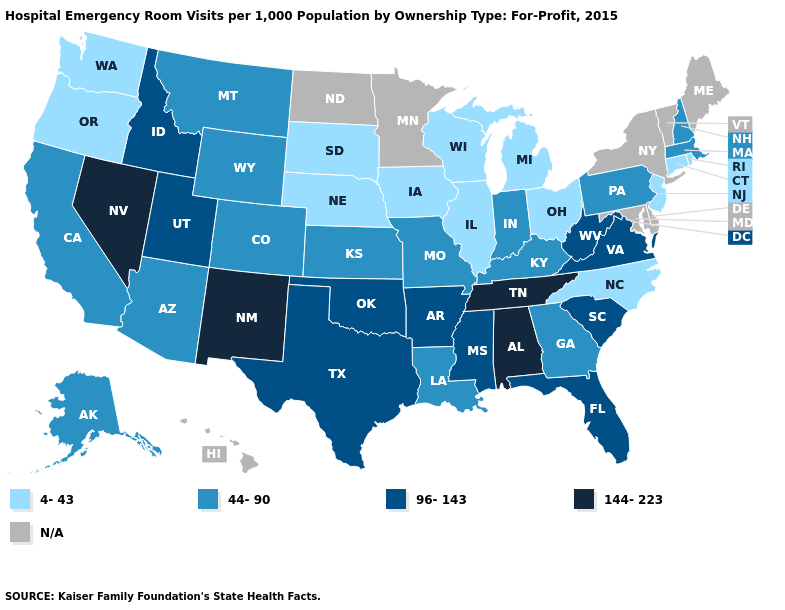What is the highest value in the West ?
Be succinct. 144-223. Name the states that have a value in the range 144-223?
Concise answer only. Alabama, Nevada, New Mexico, Tennessee. What is the value of Delaware?
Concise answer only. N/A. Name the states that have a value in the range 96-143?
Be succinct. Arkansas, Florida, Idaho, Mississippi, Oklahoma, South Carolina, Texas, Utah, Virginia, West Virginia. Which states hav the highest value in the Northeast?
Be succinct. Massachusetts, New Hampshire, Pennsylvania. Name the states that have a value in the range 144-223?
Give a very brief answer. Alabama, Nevada, New Mexico, Tennessee. Among the states that border Pennsylvania , which have the lowest value?
Answer briefly. New Jersey, Ohio. Does Missouri have the highest value in the USA?
Concise answer only. No. Which states hav the highest value in the South?
Answer briefly. Alabama, Tennessee. Among the states that border New Mexico , does Texas have the lowest value?
Answer briefly. No. Name the states that have a value in the range 144-223?
Write a very short answer. Alabama, Nevada, New Mexico, Tennessee. Name the states that have a value in the range 96-143?
Quick response, please. Arkansas, Florida, Idaho, Mississippi, Oklahoma, South Carolina, Texas, Utah, Virginia, West Virginia. What is the highest value in the USA?
Short answer required. 144-223. Name the states that have a value in the range N/A?
Be succinct. Delaware, Hawaii, Maine, Maryland, Minnesota, New York, North Dakota, Vermont. 